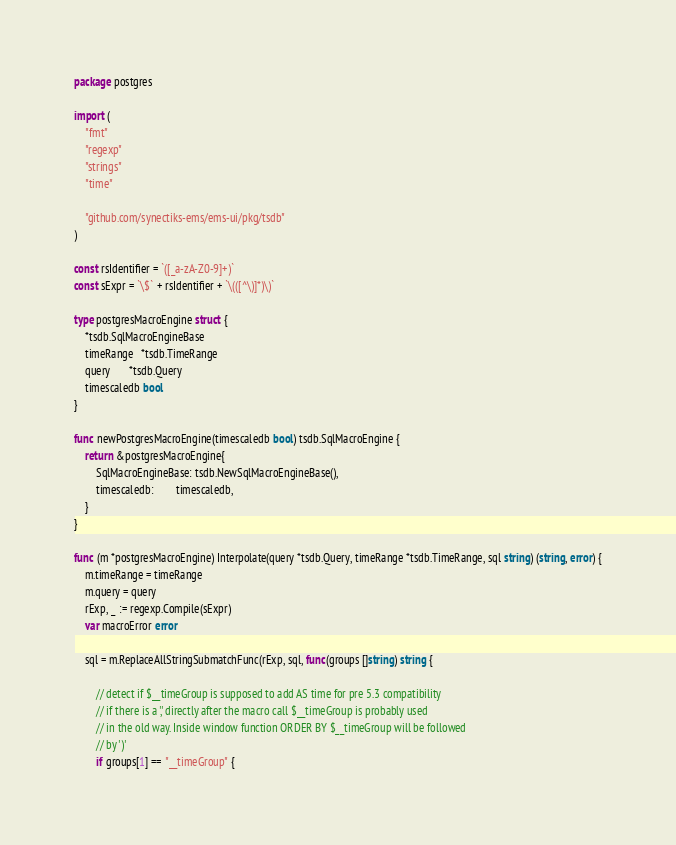<code> <loc_0><loc_0><loc_500><loc_500><_Go_>package postgres

import (
	"fmt"
	"regexp"
	"strings"
	"time"

	"github.com/synectiks-ems/ems-ui/pkg/tsdb"
)

const rsIdentifier = `([_a-zA-Z0-9]+)`
const sExpr = `\$` + rsIdentifier + `\(([^\)]*)\)`

type postgresMacroEngine struct {
	*tsdb.SqlMacroEngineBase
	timeRange   *tsdb.TimeRange
	query       *tsdb.Query
	timescaledb bool
}

func newPostgresMacroEngine(timescaledb bool) tsdb.SqlMacroEngine {
	return &postgresMacroEngine{
		SqlMacroEngineBase: tsdb.NewSqlMacroEngineBase(),
		timescaledb:        timescaledb,
	}
}

func (m *postgresMacroEngine) Interpolate(query *tsdb.Query, timeRange *tsdb.TimeRange, sql string) (string, error) {
	m.timeRange = timeRange
	m.query = query
	rExp, _ := regexp.Compile(sExpr)
	var macroError error

	sql = m.ReplaceAllStringSubmatchFunc(rExp, sql, func(groups []string) string {

		// detect if $__timeGroup is supposed to add AS time for pre 5.3 compatibility
		// if there is a ',' directly after the macro call $__timeGroup is probably used
		// in the old way. Inside window function ORDER BY $__timeGroup will be followed
		// by ')'
		if groups[1] == "__timeGroup" {</code> 